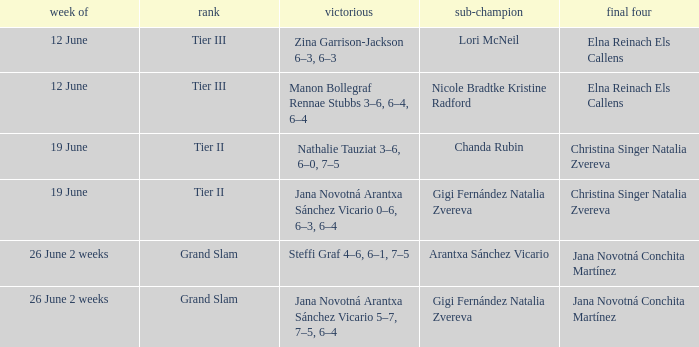Who are the semi finalists on the week of 12 june, when the runner-up is listed as Lori McNeil? Elna Reinach Els Callens. 